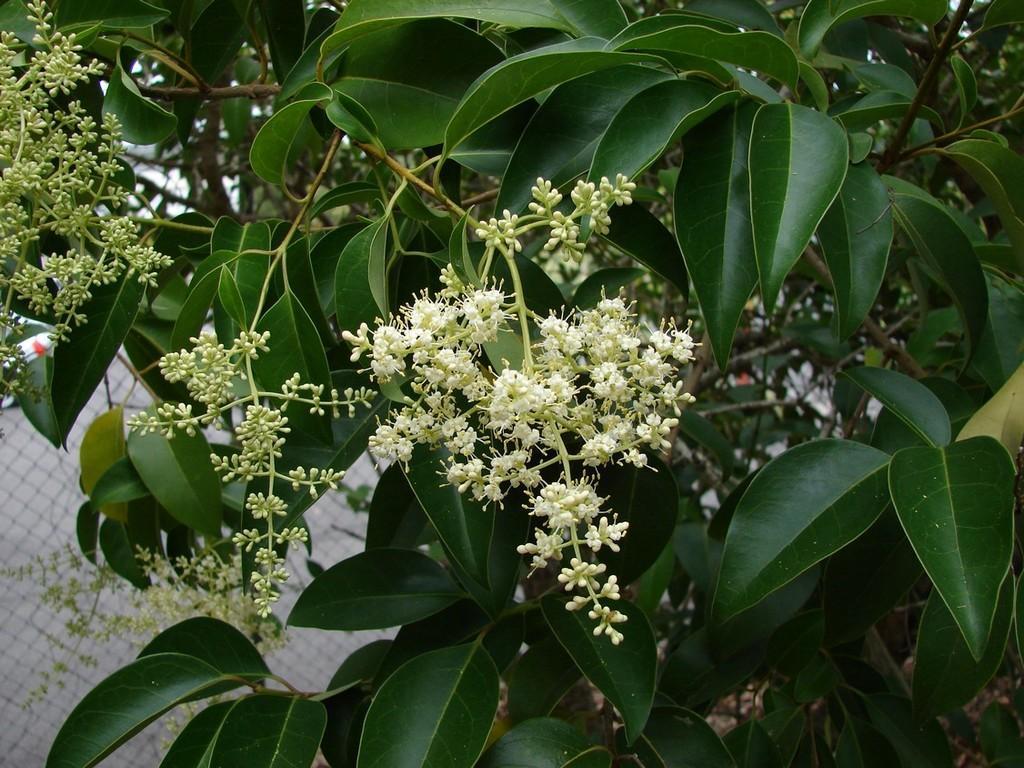Could you give a brief overview of what you see in this image? In this image we can see flowers, buds, leaves and other objects. In the background of the image there is a fence and other objects. 